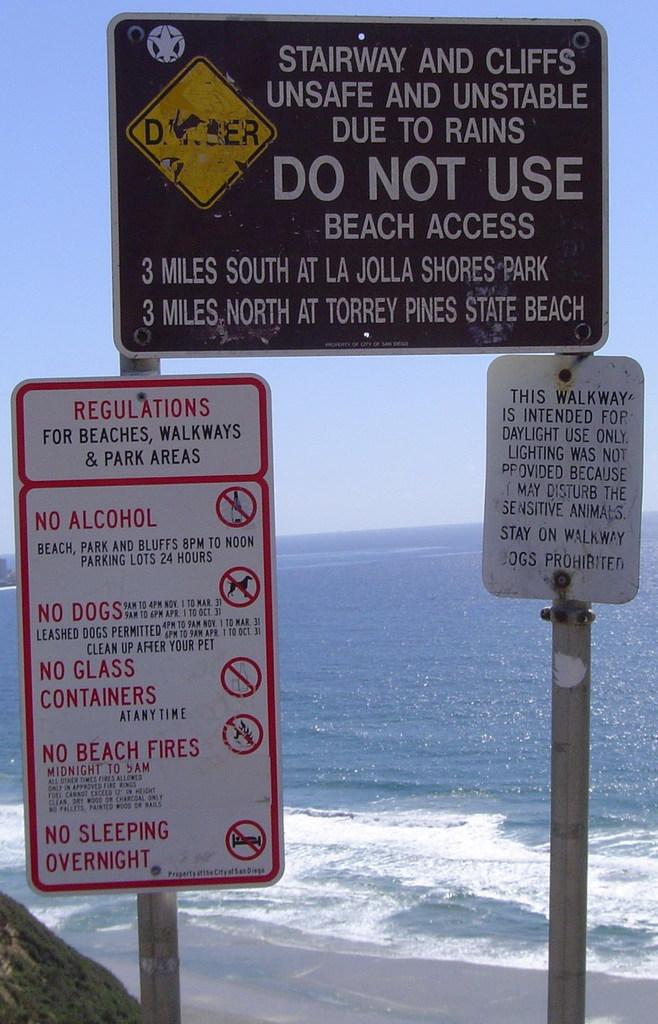Is alcohol allowed?
Your response must be concise. No. 